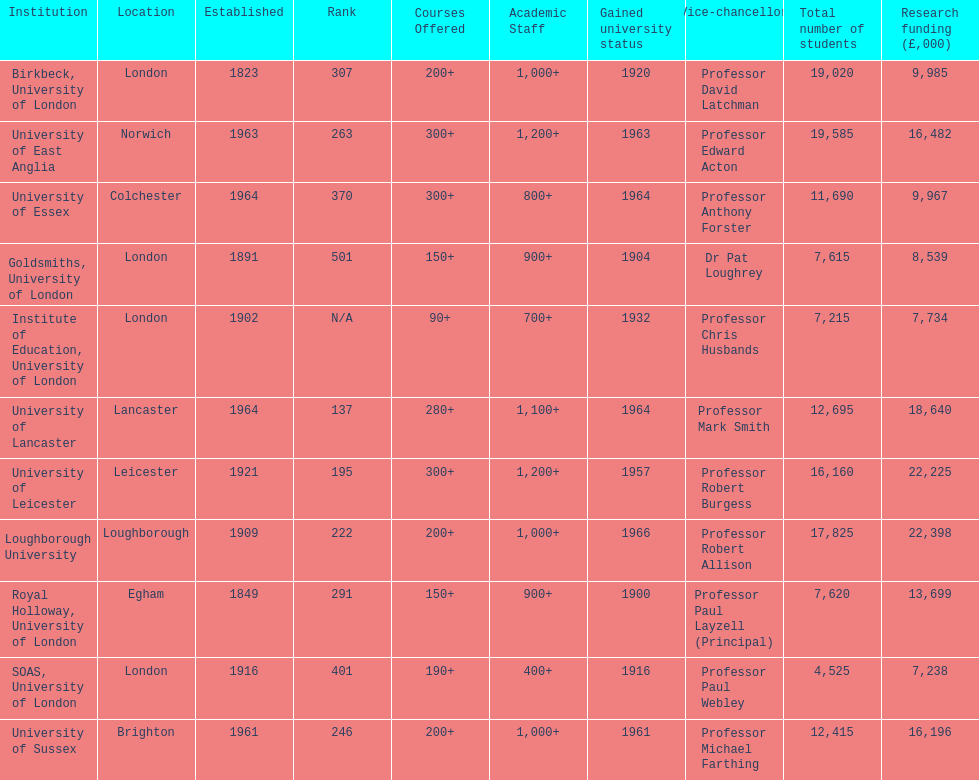Which institution has the most research funding? Loughborough University. 